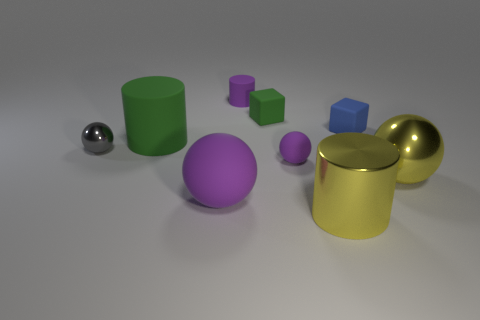Subtract all big cylinders. How many cylinders are left? 1 Subtract all brown cylinders. How many purple balls are left? 2 Subtract all yellow balls. How many balls are left? 3 Subtract 2 balls. How many balls are left? 2 Add 1 large purple objects. How many objects exist? 10 Subtract all cubes. How many objects are left? 7 Subtract all blue cylinders. Subtract all red blocks. How many cylinders are left? 3 Add 5 rubber spheres. How many rubber spheres are left? 7 Add 1 big matte cylinders. How many big matte cylinders exist? 2 Subtract 0 cyan cubes. How many objects are left? 9 